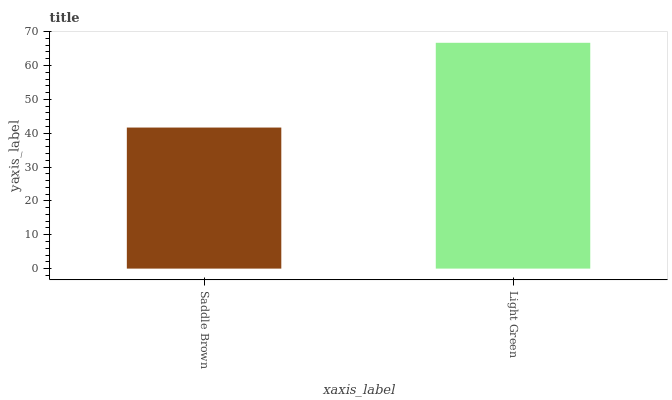Is Saddle Brown the minimum?
Answer yes or no. Yes. Is Light Green the maximum?
Answer yes or no. Yes. Is Light Green the minimum?
Answer yes or no. No. Is Light Green greater than Saddle Brown?
Answer yes or no. Yes. Is Saddle Brown less than Light Green?
Answer yes or no. Yes. Is Saddle Brown greater than Light Green?
Answer yes or no. No. Is Light Green less than Saddle Brown?
Answer yes or no. No. Is Light Green the high median?
Answer yes or no. Yes. Is Saddle Brown the low median?
Answer yes or no. Yes. Is Saddle Brown the high median?
Answer yes or no. No. Is Light Green the low median?
Answer yes or no. No. 